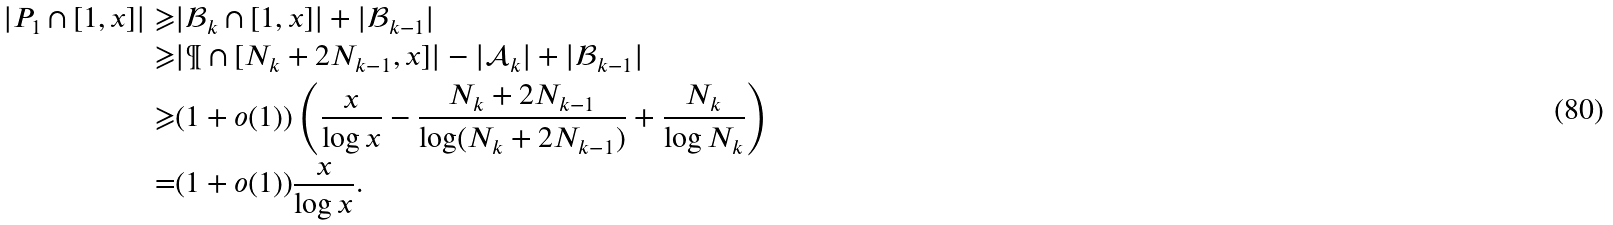Convert formula to latex. <formula><loc_0><loc_0><loc_500><loc_500>| P _ { 1 } \cap [ 1 , x ] | \geqslant & | { \mathcal { B } } _ { k } \cap [ 1 , x ] | + | { \mathcal { B } } _ { k - 1 } | \\ \geqslant & | \P \cap [ N _ { k } + 2 N _ { k - 1 } , x ] | - | { \mathcal { A } } _ { k } | + | { \mathcal { B } } _ { k - 1 } | \\ \geqslant & ( 1 + o ( 1 ) ) \left ( \frac { x } { \log x } - \frac { N _ { k } + 2 N _ { k - 1 } } { \log ( N _ { k } + 2 N _ { k - 1 } ) } + \frac { N _ { k } } { \log N _ { k } } \right ) \\ = & ( 1 + o ( 1 ) ) \frac { x } { \log x } .</formula> 